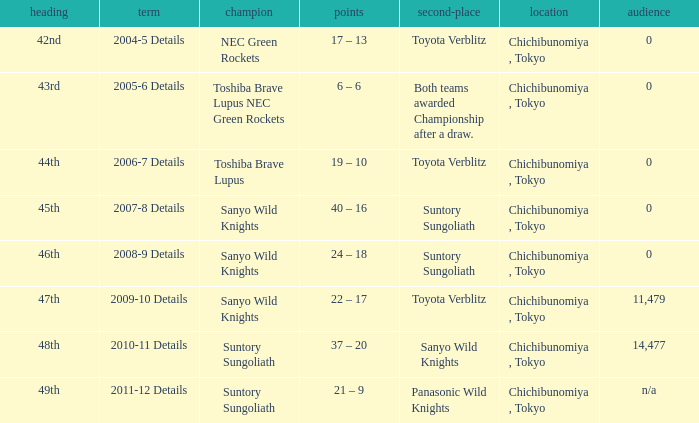What is the Score when the winner was suntory sungoliath, and the number attendance was n/a? 21 – 9. 